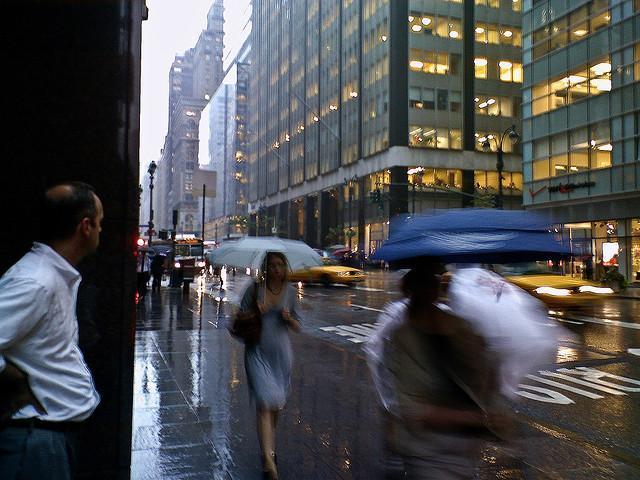How many umbrellas can be seen?
Give a very brief answer. 2. How many people are visible?
Give a very brief answer. 3. How many horses are to the left of the light pole?
Give a very brief answer. 0. 